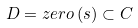<formula> <loc_0><loc_0><loc_500><loc_500>D = z e r o \left ( s \right ) \subset C</formula> 